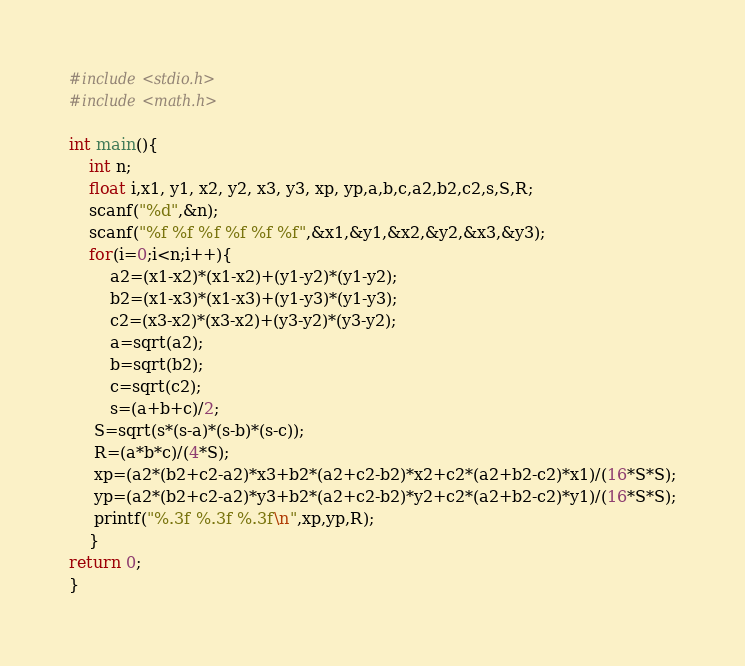<code> <loc_0><loc_0><loc_500><loc_500><_C_>#include<stdio.h>
#include<math.h>

int main(){
    int n;
    float i,x1, y1, x2, y2, x3, y3, xp, yp,a,b,c,a2,b2,c2,s,S,R;
    scanf("%d",&n);
    scanf("%f %f %f %f %f %f",&x1,&y1,&x2,&y2,&x3,&y3);
    for(i=0;i<n;i++){
   	    a2=(x1-x2)*(x1-x2)+(y1-y2)*(y1-y2);
   	    b2=(x1-x3)*(x1-x3)+(y1-y3)*(y1-y3);
    	c2=(x3-x2)*(x3-x2)+(y3-y2)*(y3-y2);
    	a=sqrt(a2);
        b=sqrt(b2);
        c=sqrt(c2);
    	s=(a+b+c)/2;
     S=sqrt(s*(s-a)*(s-b)*(s-c));
     R=(a*b*c)/(4*S);
     xp=(a2*(b2+c2-a2)*x3+b2*(a2+c2-b2)*x2+c2*(a2+b2-c2)*x1)/(16*S*S);
     yp=(a2*(b2+c2-a2)*y3+b2*(a2+c2-b2)*y2+c2*(a2+b2-c2)*y1)/(16*S*S);
     printf("%.3f %.3f %.3f\n",xp,yp,R);
    }
return 0;
}</code> 